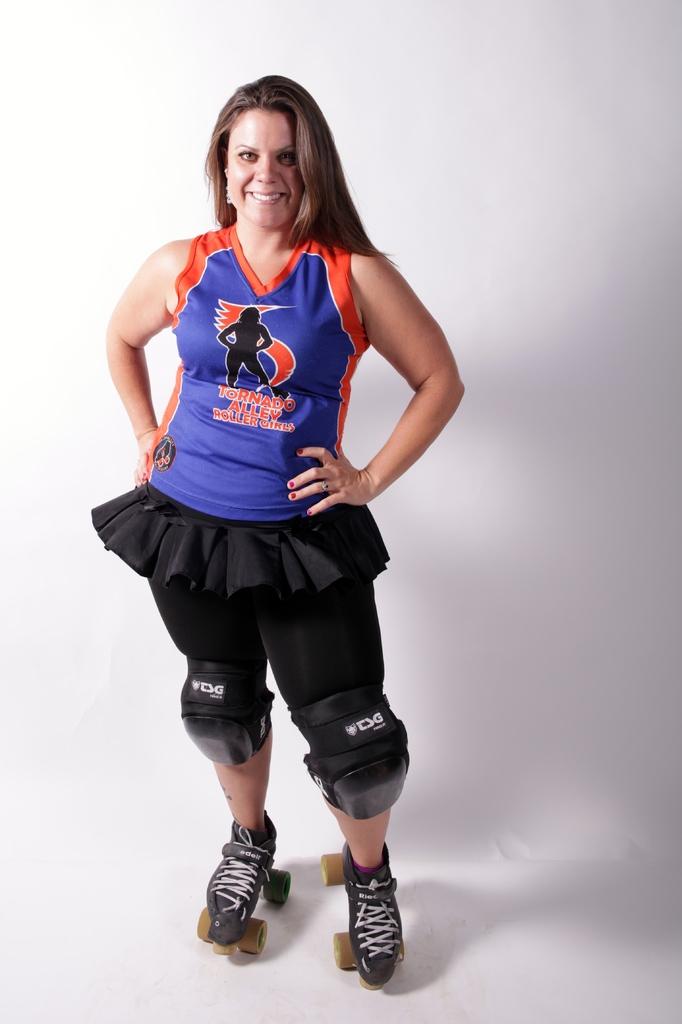What team does she play on?
Give a very brief answer. Tornado alley roller girls. 